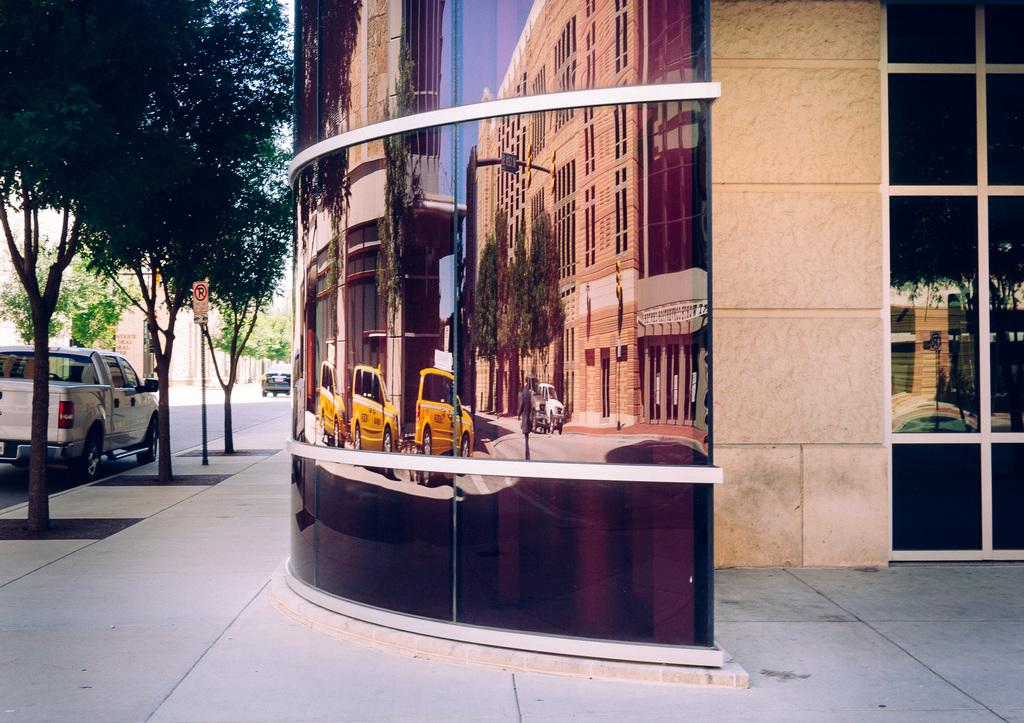What type of structures can be seen in the image? There are buildings in the image. What type of vehicles are present in the image? There are cars in the image. What type of natural elements can be seen in the image? There are trees in the image. What type of pathway is visible in the image? There is a road in the image. What type of informational display is present in the image? There is a sign board in the image. What is visible in the upper part of the image? The sky is visible in the image. What type of feeling can be seen in the image? Feelings cannot be seen in an image, as they are emotions experienced by individuals and not visible objects. Is there a camp visible in the image? There is no camp present in the image. 